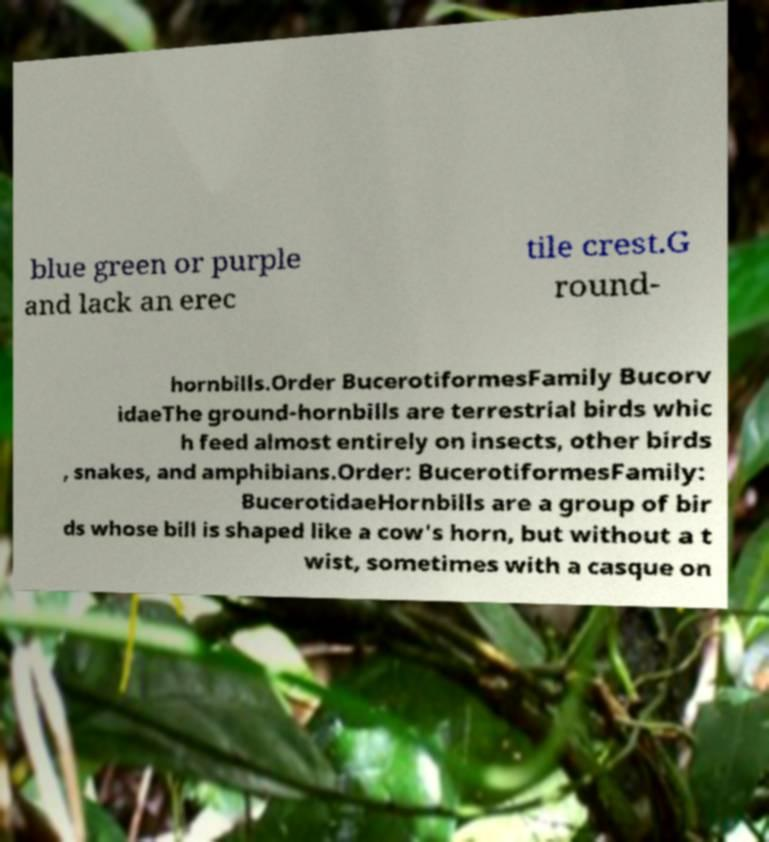Could you extract and type out the text from this image? blue green or purple and lack an erec tile crest.G round- hornbills.Order BucerotiformesFamily Bucorv idaeThe ground-hornbills are terrestrial birds whic h feed almost entirely on insects, other birds , snakes, and amphibians.Order: BucerotiformesFamily: BucerotidaeHornbills are a group of bir ds whose bill is shaped like a cow's horn, but without a t wist, sometimes with a casque on 